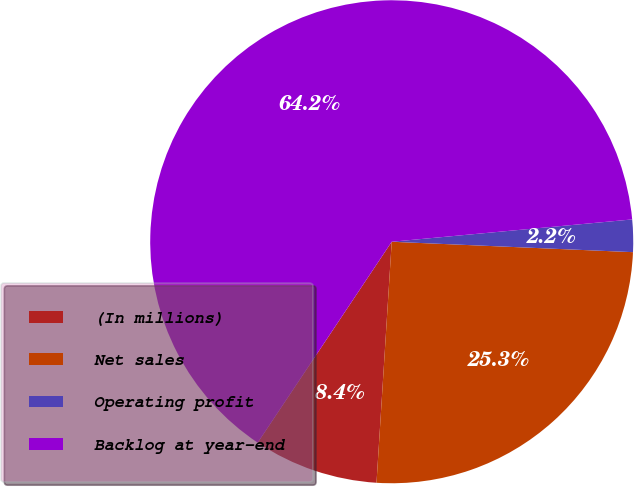Convert chart. <chart><loc_0><loc_0><loc_500><loc_500><pie_chart><fcel>(In millions)<fcel>Net sales<fcel>Operating profit<fcel>Backlog at year-end<nl><fcel>8.36%<fcel>25.32%<fcel>2.16%<fcel>64.17%<nl></chart> 